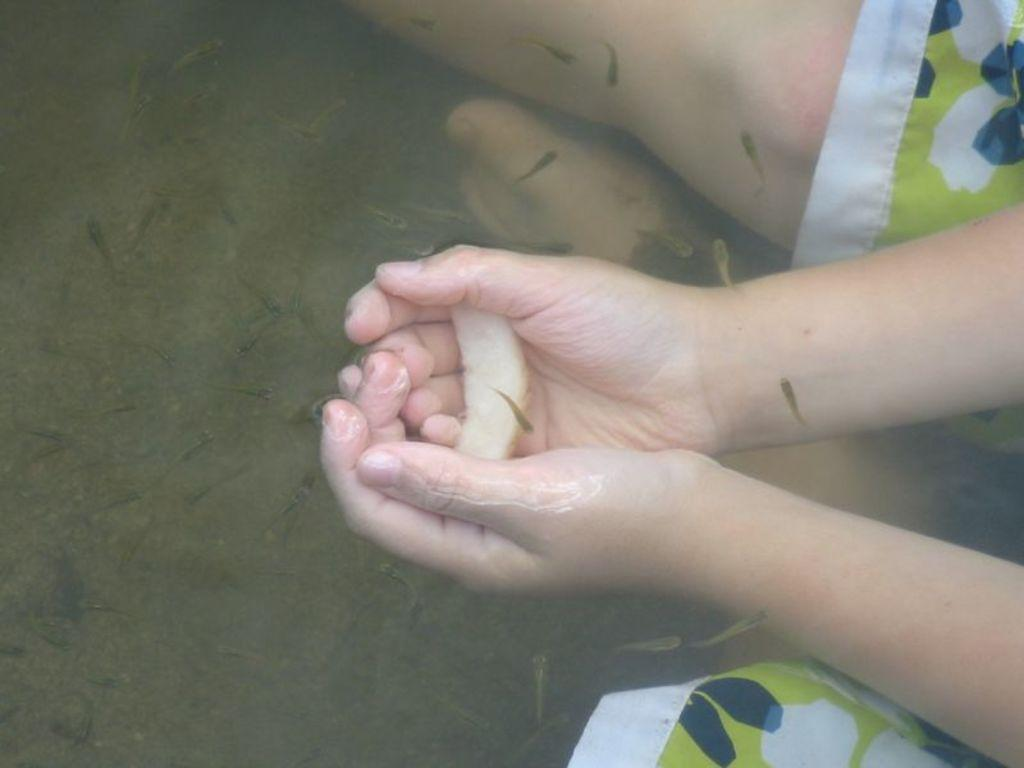What is the person in the image doing? There is a person in the water body. What is the person holding in the image? The person is holding something. Can you describe the environment around the person? There are many small fishes in the water. What type of haircut does the duck have in the image? There is no duck present in the image, so it is not possible to determine the type of haircut it might have. 